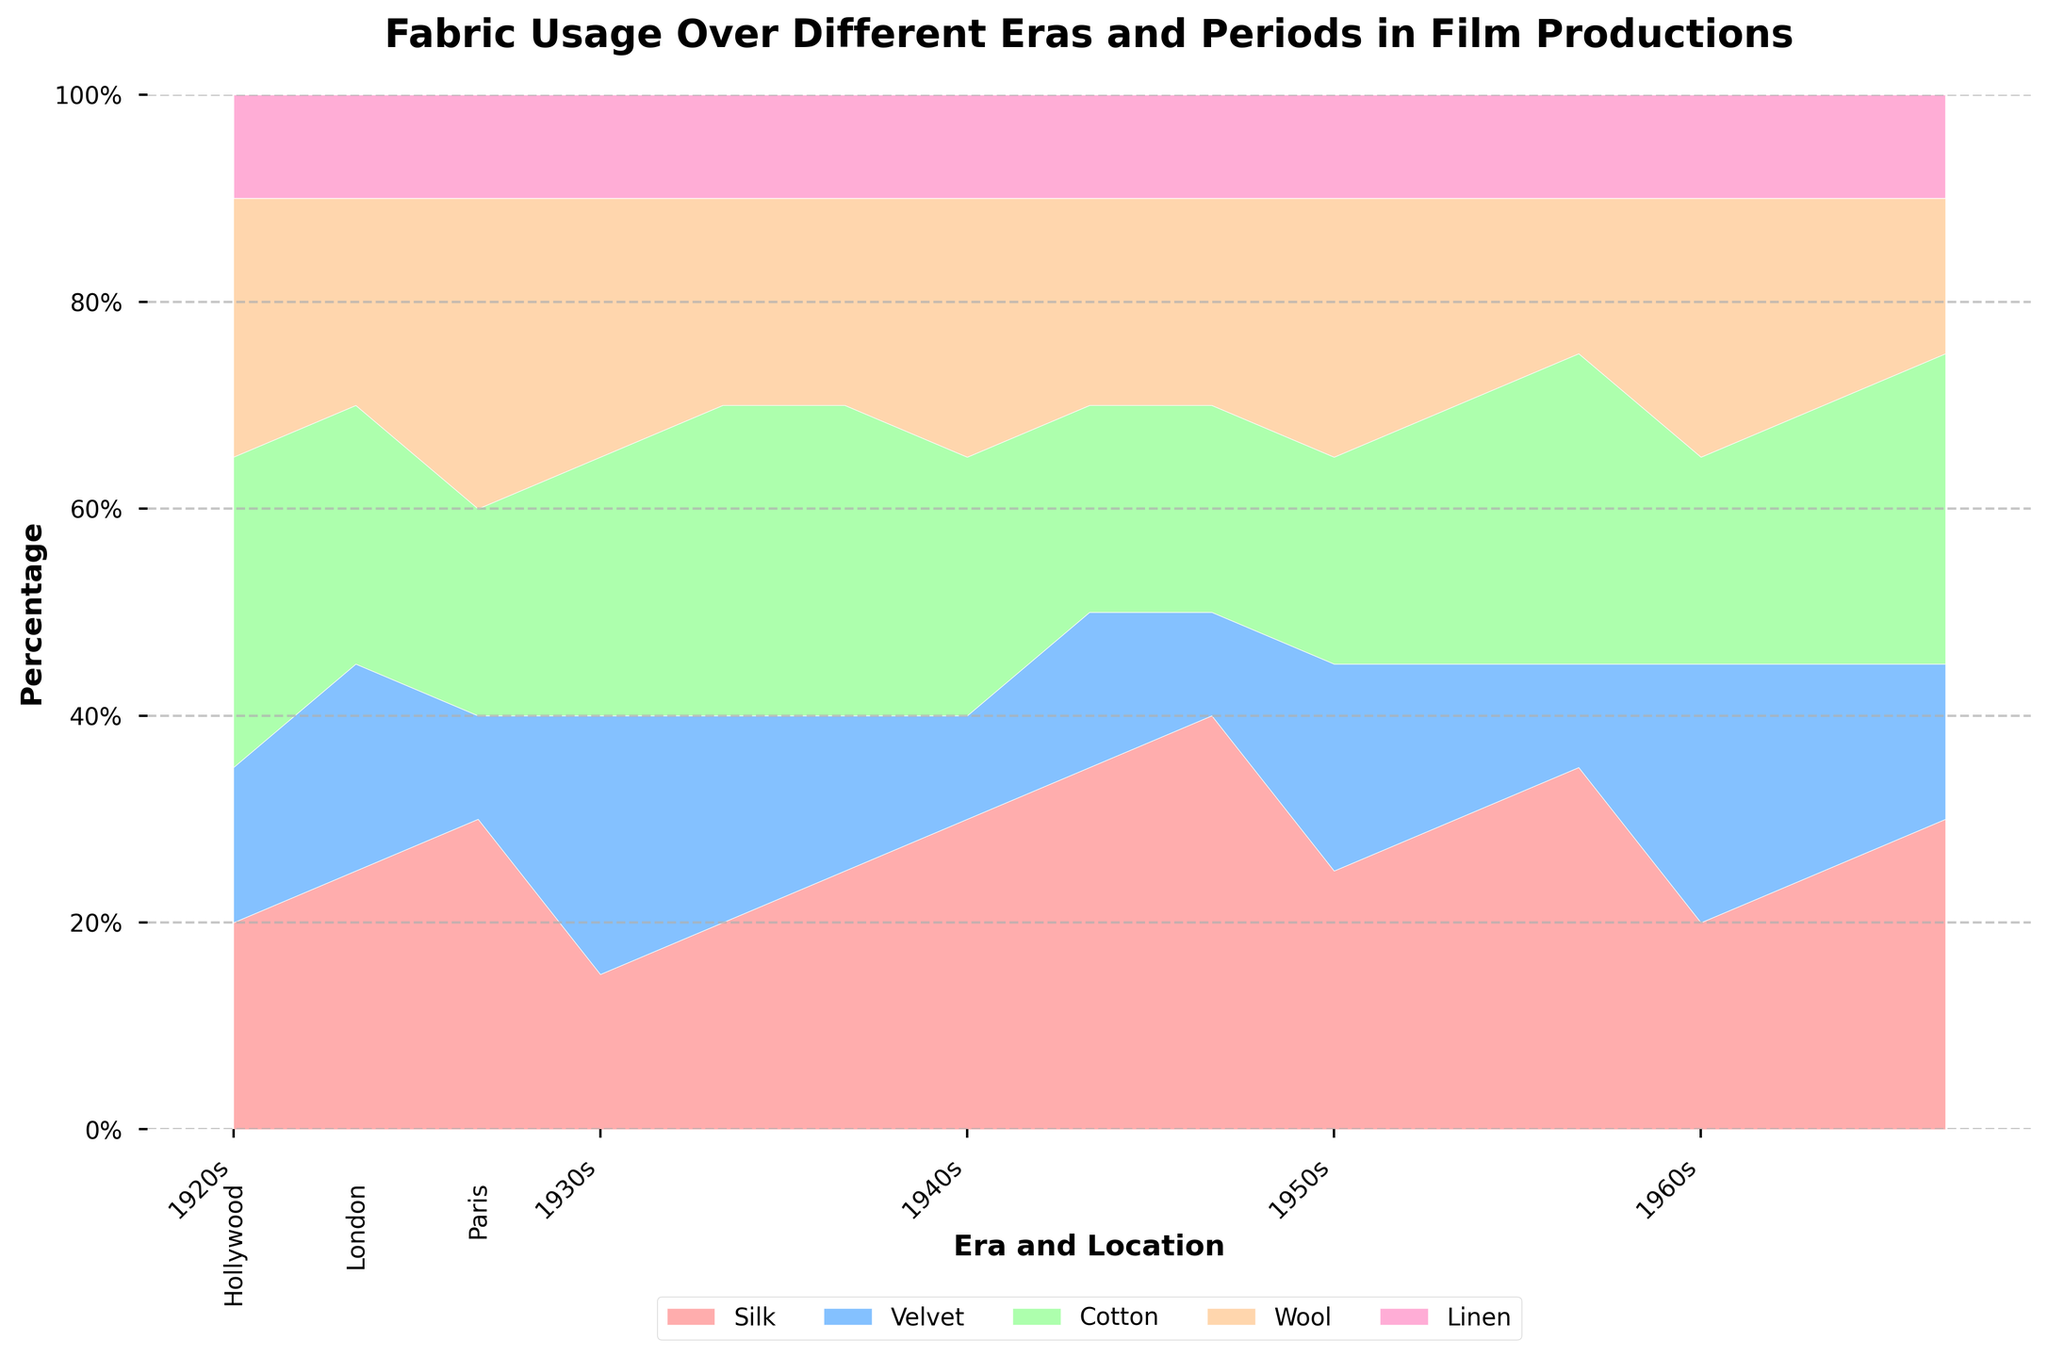Which fabric is most prevalent in the Hollywood locations during the 1960s? Identify the section of the chart representing Hollywood in the 1960s and observe the area contributions of each fabric to find the most prevalent one.
Answer: Velvet What is the total percentage of Silk used across all locations in the 1940s? Inspect the section of the chart corresponding to the 1940s and sum the Silk values across Hollywood, London, and Paris.
Answer: 105% Which era and location combinations have the highest and lowest percentage use of Linen? Determine the segments in each era for Linen and compare the heights to find the highest and the lowest.
Answer: All areas have equal percentages for Linen per era How does the usage of Velvet change from the 1920s to the 1950s in Paris? Look at the Paris sections for the 1920s and 1950s and compare the Velvet areas.
Answer: Decreases from 1920s to 1950s What is the average percentage use of Cotton in London throughout all eras shown? Sum Cotton values across all recorded years for London and divide by the number of eras.
Answer: 27.5% Is Wool more commonly used in Hollywood or Paris throughout the depicted eras? Compare the overall area contributions of Wool in Hollywood and Paris across different eras.
Answer: Hollywood Which fabric remains consistent in its percentage usage throughout all eras? Look for fabrics that maintain similar heights in their segments across all eras.
Answer: Linen In the 1930s, which location has the highest percentage usage of Velvet? Identify the Velvet segments for each location in the 1930s and find the highest one.
Answer: Hollywood By how much does the use of Silk in Hollywood decrease from the 1940s to the 1960s? Subtract the Silk percentage in Hollywood for the 1960s from that in the 1940s.
Answer: 10% Compare the Cotton usage in Paris across all eras; which era shows the highest increase? Examine the Cotton segments in Paris across all eras and find the era with the steepest increase.
Answer: 1950s 